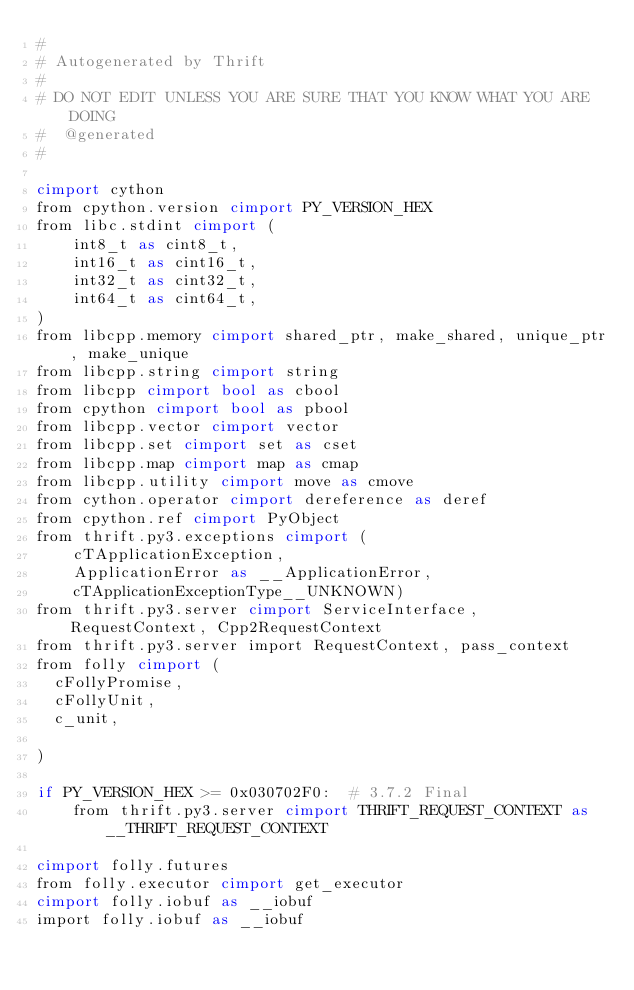<code> <loc_0><loc_0><loc_500><loc_500><_Cython_>#
# Autogenerated by Thrift
#
# DO NOT EDIT UNLESS YOU ARE SURE THAT YOU KNOW WHAT YOU ARE DOING
#  @generated
#

cimport cython
from cpython.version cimport PY_VERSION_HEX
from libc.stdint cimport (
    int8_t as cint8_t,
    int16_t as cint16_t,
    int32_t as cint32_t,
    int64_t as cint64_t,
)
from libcpp.memory cimport shared_ptr, make_shared, unique_ptr, make_unique
from libcpp.string cimport string
from libcpp cimport bool as cbool
from cpython cimport bool as pbool
from libcpp.vector cimport vector
from libcpp.set cimport set as cset
from libcpp.map cimport map as cmap
from libcpp.utility cimport move as cmove
from cython.operator cimport dereference as deref
from cpython.ref cimport PyObject
from thrift.py3.exceptions cimport (
    cTApplicationException,
    ApplicationError as __ApplicationError,
    cTApplicationExceptionType__UNKNOWN)
from thrift.py3.server cimport ServiceInterface, RequestContext, Cpp2RequestContext
from thrift.py3.server import RequestContext, pass_context
from folly cimport (
  cFollyPromise,
  cFollyUnit,
  c_unit,

)

if PY_VERSION_HEX >= 0x030702F0:  # 3.7.2 Final
    from thrift.py3.server cimport THRIFT_REQUEST_CONTEXT as __THRIFT_REQUEST_CONTEXT

cimport folly.futures
from folly.executor cimport get_executor
cimport folly.iobuf as __iobuf
import folly.iobuf as __iobuf</code> 